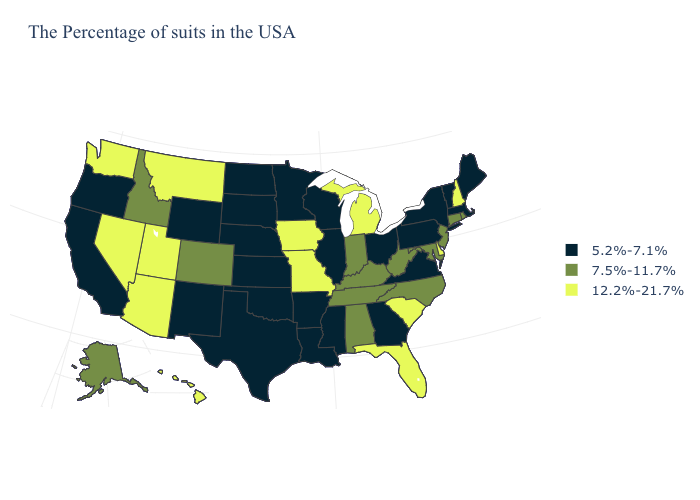Does South Dakota have a lower value than Arizona?
Concise answer only. Yes. Is the legend a continuous bar?
Quick response, please. No. Name the states that have a value in the range 7.5%-11.7%?
Give a very brief answer. Rhode Island, Connecticut, New Jersey, Maryland, North Carolina, West Virginia, Kentucky, Indiana, Alabama, Tennessee, Colorado, Idaho, Alaska. Name the states that have a value in the range 7.5%-11.7%?
Concise answer only. Rhode Island, Connecticut, New Jersey, Maryland, North Carolina, West Virginia, Kentucky, Indiana, Alabama, Tennessee, Colorado, Idaho, Alaska. What is the highest value in states that border Connecticut?
Write a very short answer. 7.5%-11.7%. What is the value of Pennsylvania?
Short answer required. 5.2%-7.1%. Does Oregon have the highest value in the West?
Keep it brief. No. What is the value of Vermont?
Write a very short answer. 5.2%-7.1%. Which states hav the highest value in the MidWest?
Quick response, please. Michigan, Missouri, Iowa. What is the lowest value in states that border Nevada?
Short answer required. 5.2%-7.1%. Name the states that have a value in the range 7.5%-11.7%?
Write a very short answer. Rhode Island, Connecticut, New Jersey, Maryland, North Carolina, West Virginia, Kentucky, Indiana, Alabama, Tennessee, Colorado, Idaho, Alaska. Which states have the lowest value in the MidWest?
Concise answer only. Ohio, Wisconsin, Illinois, Minnesota, Kansas, Nebraska, South Dakota, North Dakota. What is the value of Maryland?
Short answer required. 7.5%-11.7%. What is the highest value in states that border Vermont?
Give a very brief answer. 12.2%-21.7%. Is the legend a continuous bar?
Give a very brief answer. No. 